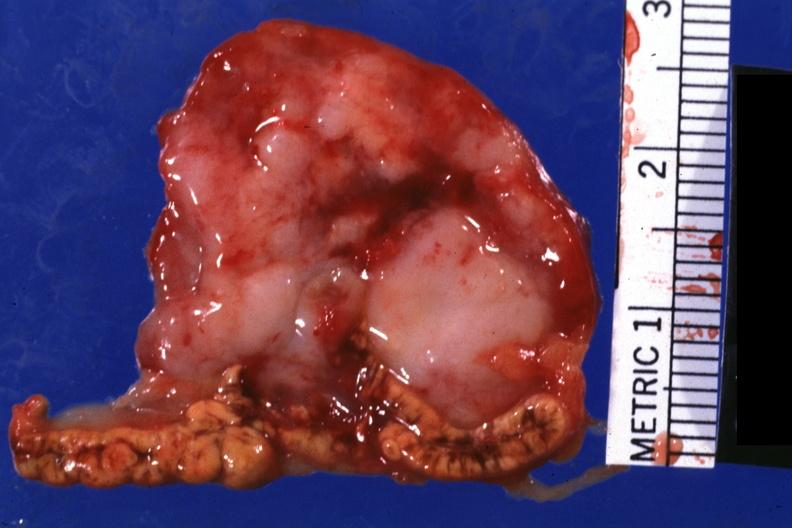s metastatic carcinoma present?
Answer the question using a single word or phrase. Yes 